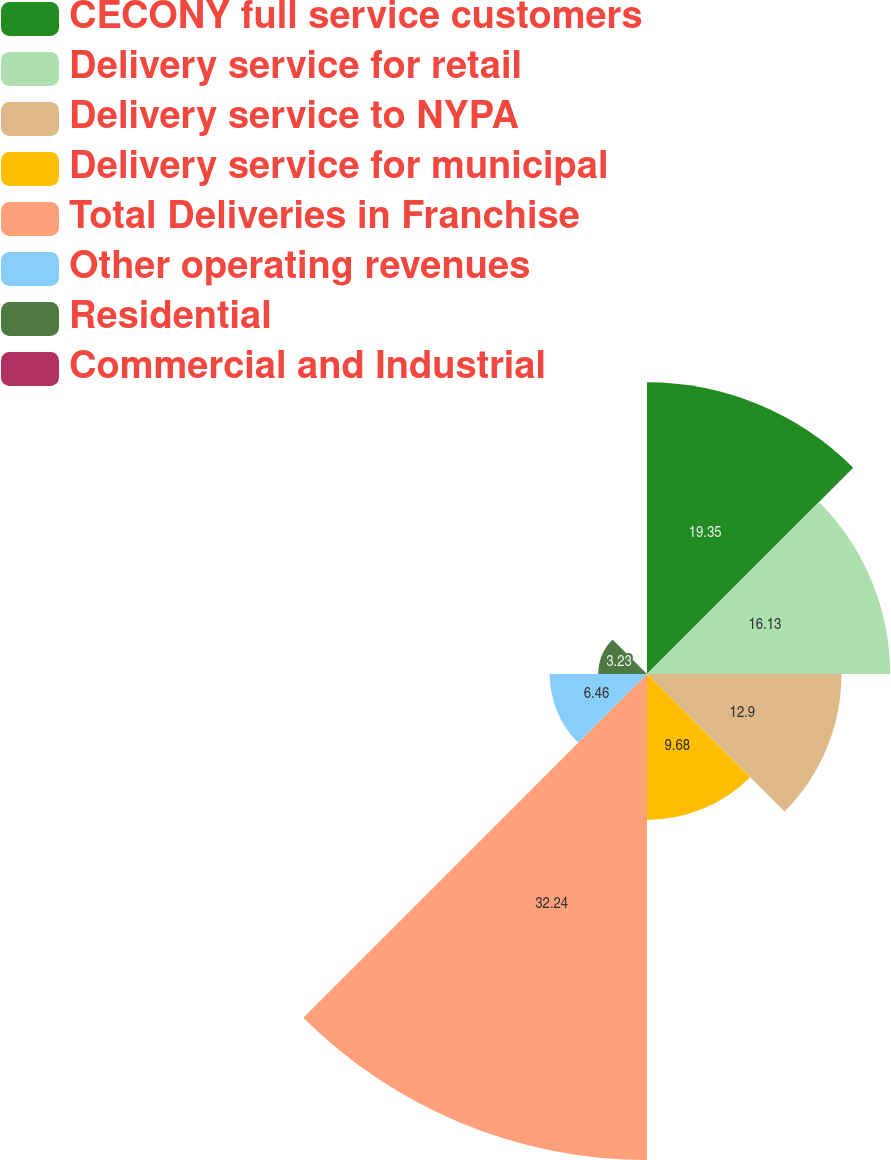<chart> <loc_0><loc_0><loc_500><loc_500><pie_chart><fcel>CECONY full service customers<fcel>Delivery service for retail<fcel>Delivery service to NYPA<fcel>Delivery service for municipal<fcel>Total Deliveries in Franchise<fcel>Other operating revenues<fcel>Residential<fcel>Commercial and Industrial<nl><fcel>19.35%<fcel>16.13%<fcel>12.9%<fcel>9.68%<fcel>32.24%<fcel>6.46%<fcel>3.23%<fcel>0.01%<nl></chart> 